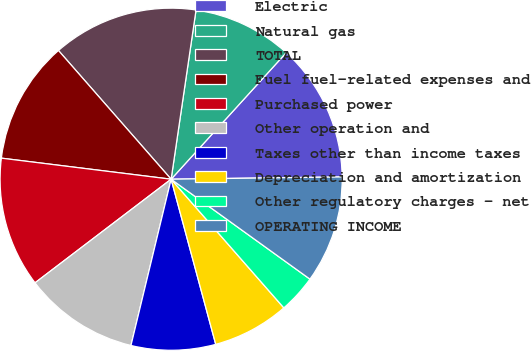Convert chart. <chart><loc_0><loc_0><loc_500><loc_500><pie_chart><fcel>Electric<fcel>Natural gas<fcel>TOTAL<fcel>Fuel fuel-related expenses and<fcel>Purchased power<fcel>Other operation and<fcel>Taxes other than income taxes<fcel>Depreciation and amortization<fcel>Other regulatory charges - net<fcel>OPERATING INCOME<nl><fcel>13.04%<fcel>9.42%<fcel>13.77%<fcel>11.59%<fcel>12.32%<fcel>10.87%<fcel>7.97%<fcel>7.25%<fcel>3.62%<fcel>10.14%<nl></chart> 